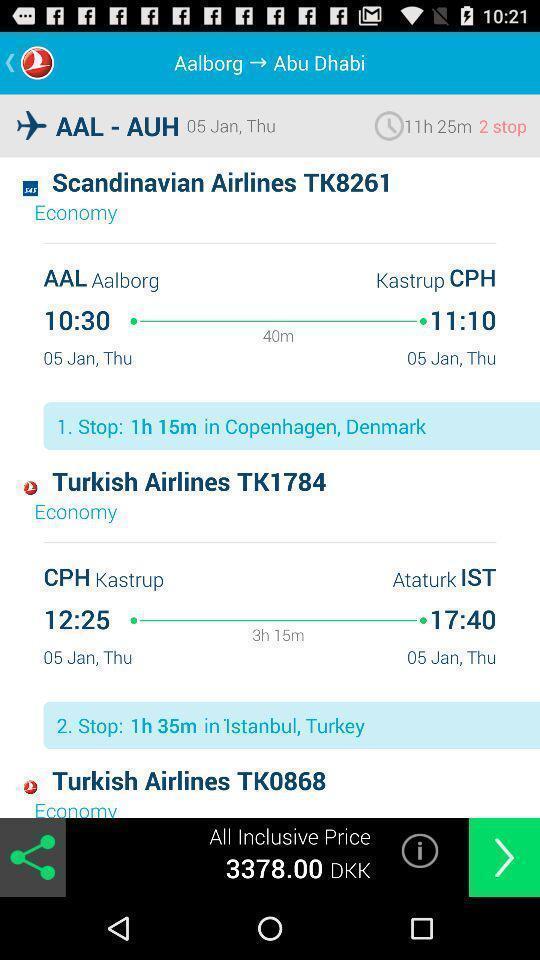Give me a summary of this screen capture. Page displaying various flight details in booking application. 